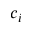Convert formula to latex. <formula><loc_0><loc_0><loc_500><loc_500>c _ { i }</formula> 